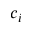Convert formula to latex. <formula><loc_0><loc_0><loc_500><loc_500>c _ { i }</formula> 